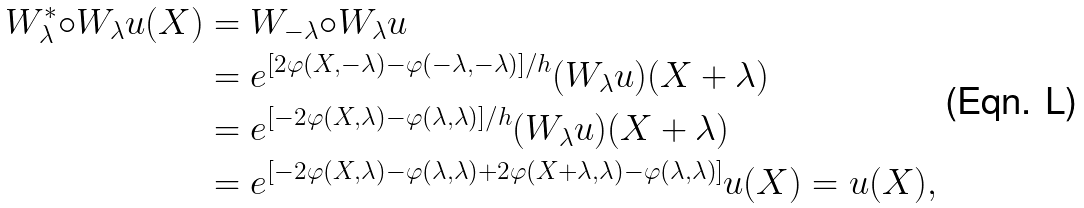Convert formula to latex. <formula><loc_0><loc_0><loc_500><loc_500>W _ { \lambda } ^ { \ast } { \circ } W _ { \lambda } u ( X ) & = W _ { - \lambda } { \circ } W _ { \lambda } u \\ & = e ^ { [ 2 \varphi ( X , - \lambda ) - \varphi ( - \lambda , - \lambda ) ] / h } ( W _ { \lambda } u ) ( X + \lambda ) \\ & = e ^ { [ - 2 \varphi ( X , \lambda ) - \varphi ( \lambda , \lambda ) ] / h } ( W _ { \lambda } u ) ( X + \lambda ) \\ & = e ^ { [ - 2 \varphi ( X , \lambda ) - \varphi ( \lambda , \lambda ) + 2 \varphi ( X + \lambda , \lambda ) - \varphi ( \lambda , \lambda ) ] } u ( X ) = u ( X ) ,</formula> 